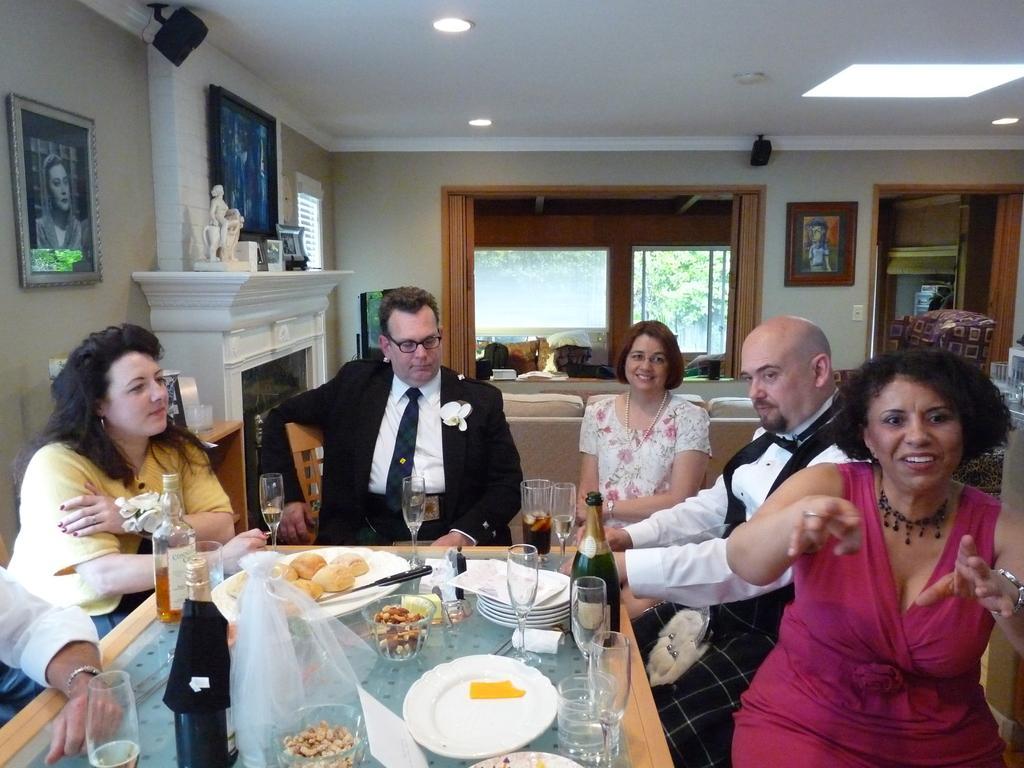Could you give a brief overview of what you see in this image? This picture is of inside the room. On the right there is a woman wearing pink color dress, smiling and sitting on the chair. There is a man and and another woman wearing white color dress, smiling and sitting on the chairs. In the center there is a man wearing suit and sitting on the chair. On the left there is a woman wearing yellow color t-shirt and sitting on the chair. In the center there is a table on the top of which food items, plates, glasses and bottles are placed. In the top left there is a fire place on the top of which sculpture and some show pieces are placed. In the background we can see the window, couch, curtain, door, wall, picture frames hanging on the wall and tree through the window. 